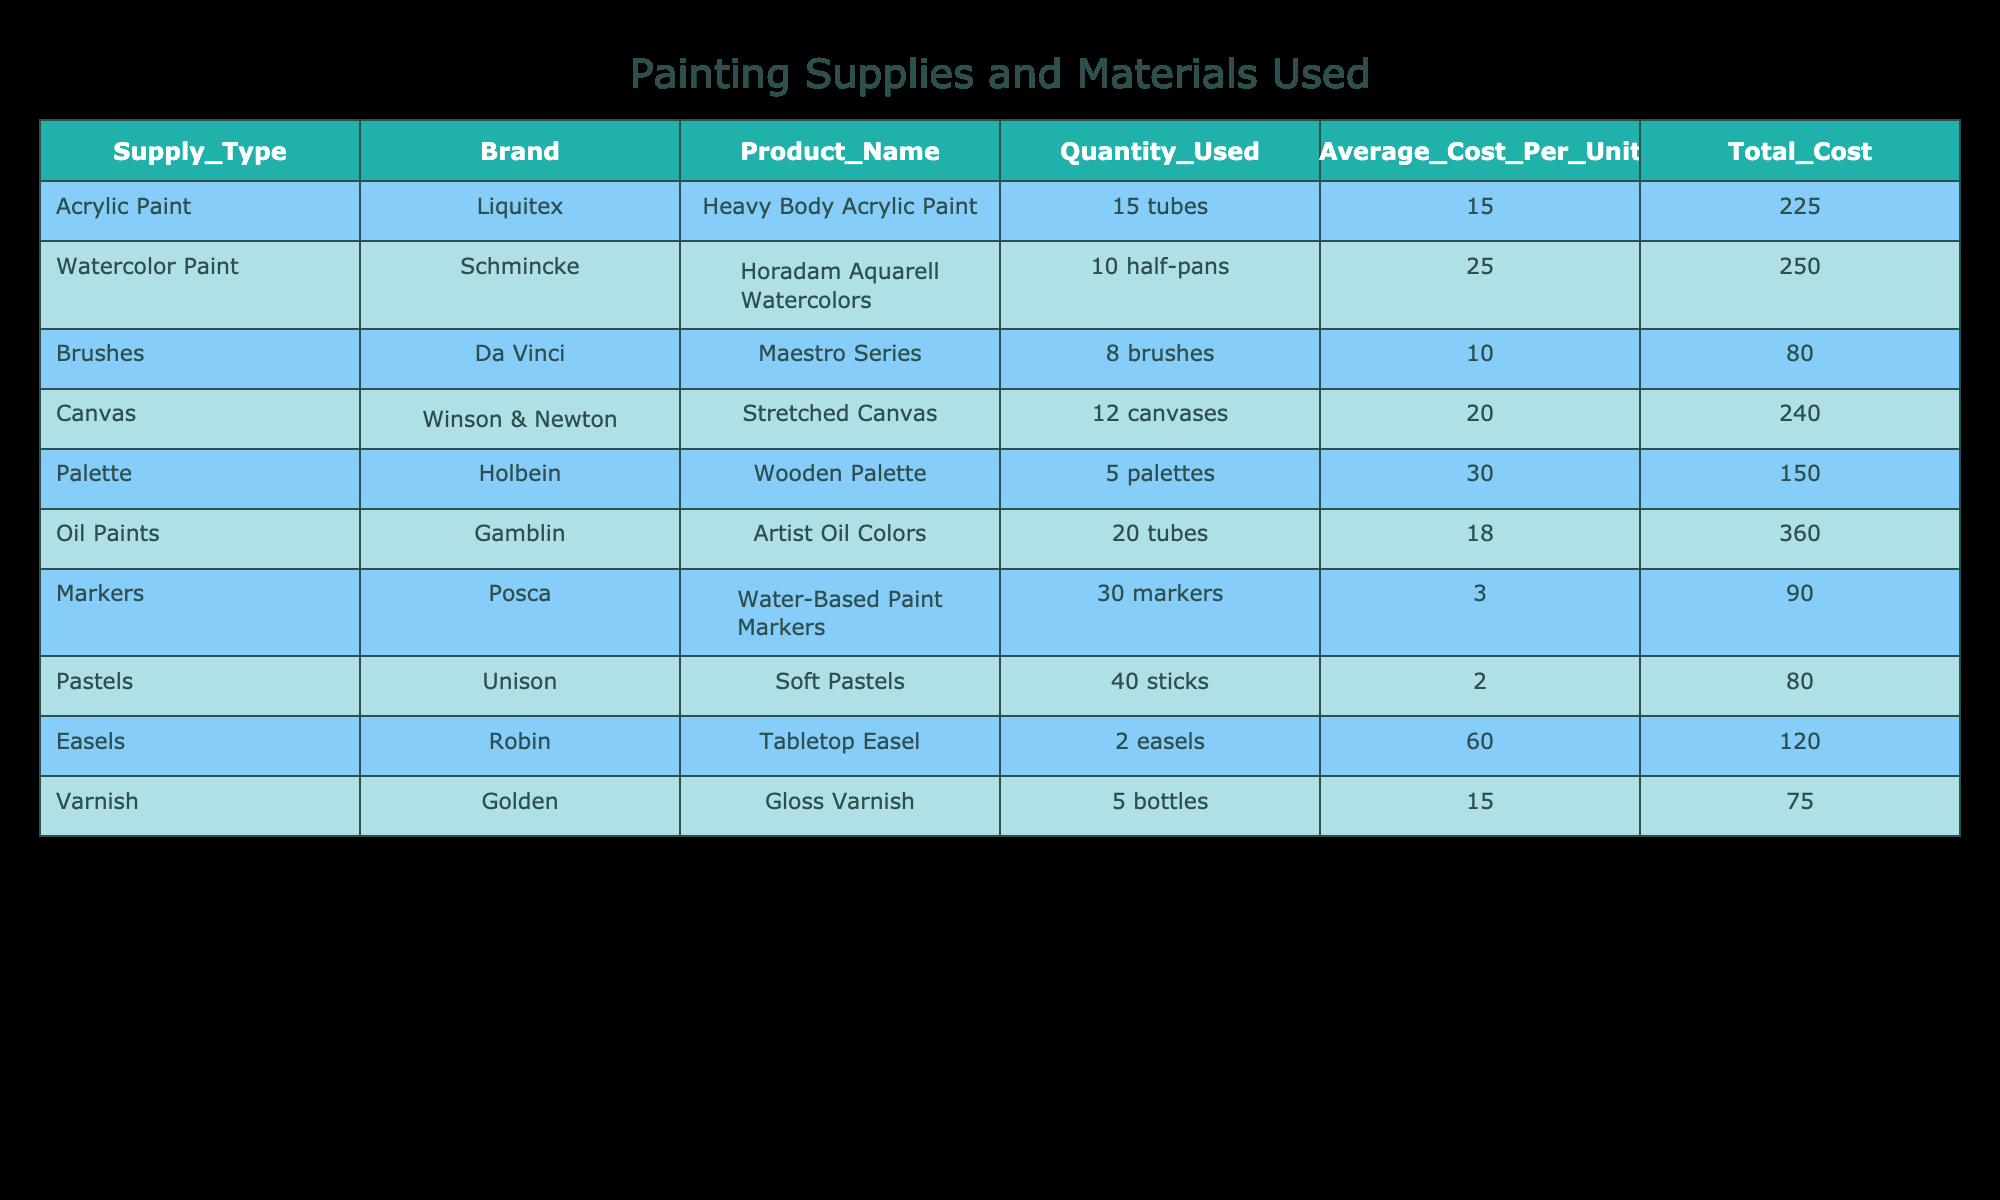What is the total cost of all painting supplies used? To find the total cost, we add the Total Cost for each supply type: 225 + 250 + 80 + 240 + 150 + 360 + 90 + 80 + 120 + 75 = 1,650
Answer: 1,650 Which type of paint had the highest average cost per unit? By comparing the Average Cost Per Unit column: Acrylic Paint (15), Watercolor Paint (25), Oil Paints (18), the highest is Watercolor Paint at 25.
Answer: Watercolor Paint How many more markers were used than canvases? We subtract the Quantity Used of canvases (12) from markers (30): 30 - 12 = 18, thus 18 more markers were used.
Answer: 18 Is the total cost of brushes greater than the total cost of Varnish? The total cost of brushes is 80 while the total cost of Varnish is 75. Since 80 is greater than 75, the answer is yes.
Answer: Yes What is the average total cost of each type of paint used? We have two types of paint: Acrylic and Oil. Their total costs are 225 and 360, respectively. The average is (225 + 360) / 2 = 292.5.
Answer: 292.5 How many units of pastels were used compared to the total units of paint (Acrylic, Watercolor, and Oil)? Total units of paint: Acrylic (15) + Watercolor (10) + Oil (20) = 45. Pastels used are 40, thus 40 used compared to 45 paints.
Answer: 40 compared to 45 Which supply type had the highest quantity used? Check the Quantity Used column: Markers (30), Pastels (40) shows Pastels had the highest usage.
Answer: Pastels What is the total cost for all types of paint combined? Total costs for all types of paint are: Acrylic (225) + Watercolor (250) + Oil Paints (360) = 835.
Answer: 835 Are there more brushes or easels used? The Quantity Used for brushes is 8, while for easels it is 2. Since 8 is greater than 2, the answer is yes.
Answer: Yes 